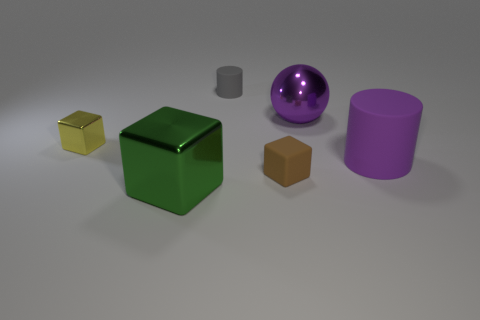Subtract all metal cubes. How many cubes are left? 1 Add 2 tiny green rubber objects. How many objects exist? 8 Subtract all cylinders. How many objects are left? 4 Subtract 1 cubes. How many cubes are left? 2 Subtract all gray cylinders. How many cylinders are left? 1 Subtract all red cylinders. Subtract all brown spheres. How many cylinders are left? 2 Subtract all balls. Subtract all tiny brown matte blocks. How many objects are left? 4 Add 4 big green shiny cubes. How many big green shiny cubes are left? 5 Add 3 small gray matte things. How many small gray matte things exist? 4 Subtract 1 yellow blocks. How many objects are left? 5 